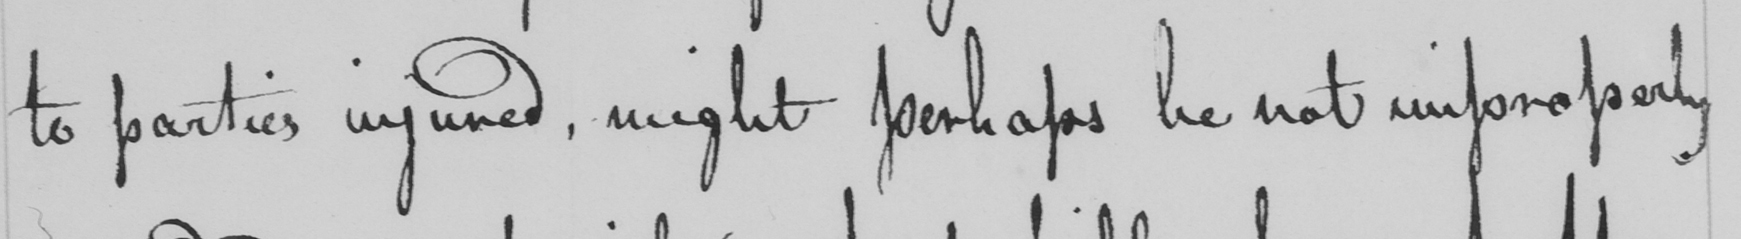Please transcribe the handwritten text in this image. to parties injured, might perhaps be not improperly 